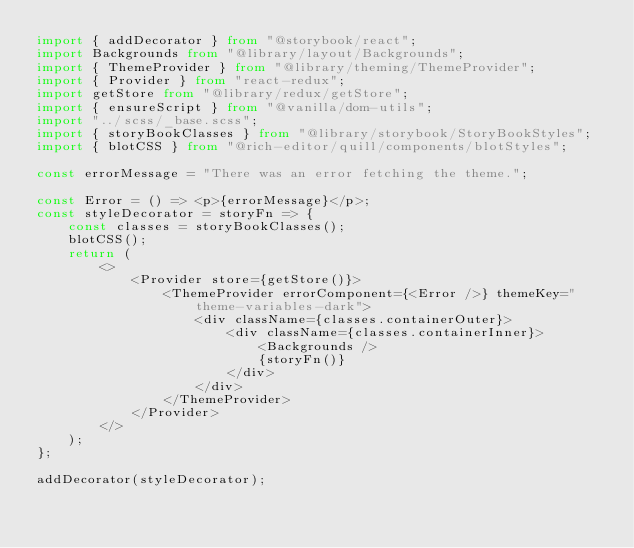<code> <loc_0><loc_0><loc_500><loc_500><_TypeScript_>import { addDecorator } from "@storybook/react";
import Backgrounds from "@library/layout/Backgrounds";
import { ThemeProvider } from "@library/theming/ThemeProvider";
import { Provider } from "react-redux";
import getStore from "@library/redux/getStore";
import { ensureScript } from "@vanilla/dom-utils";
import "../scss/_base.scss";
import { storyBookClasses } from "@library/storybook/StoryBookStyles";
import { blotCSS } from "@rich-editor/quill/components/blotStyles";

const errorMessage = "There was an error fetching the theme.";

const Error = () => <p>{errorMessage}</p>;
const styleDecorator = storyFn => {
    const classes = storyBookClasses();
    blotCSS();
    return (
        <>
            <Provider store={getStore()}>
                <ThemeProvider errorComponent={<Error />} themeKey="theme-variables-dark">
                    <div className={classes.containerOuter}>
                        <div className={classes.containerInner}>
                            <Backgrounds />
                            {storyFn()}
                        </div>
                    </div>
                </ThemeProvider>
            </Provider>
        </>
    );
};

addDecorator(styleDecorator);
</code> 